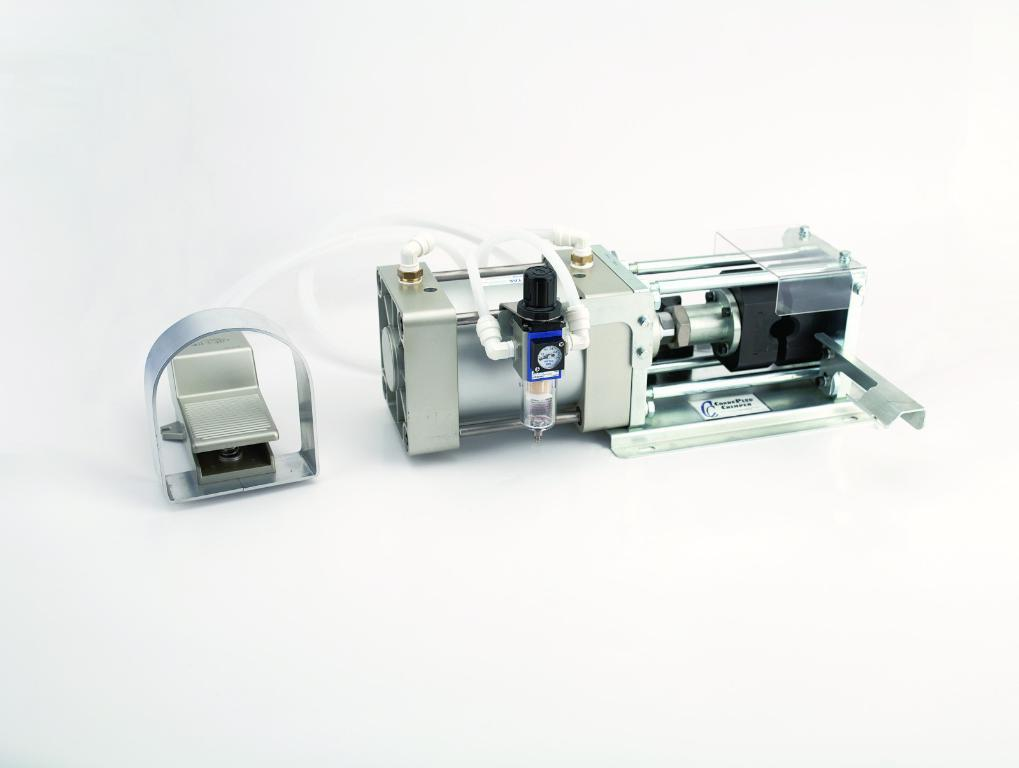What is the main object in the image? There is a machine in the image. Can you describe the appearance of the machine? The machine is silver and grey in color. What can be seen connected to the machine? There are white-colored pipes connected to the machine. What is the color of the background in the image? The background of the image is white. How many bears are visible in the image? There are no bears present in the image. What is the machine doing to increase the speed of the process? The image does not provide information about the machine's function or purpose, so it cannot be determined if it is increasing the speed of any process. 